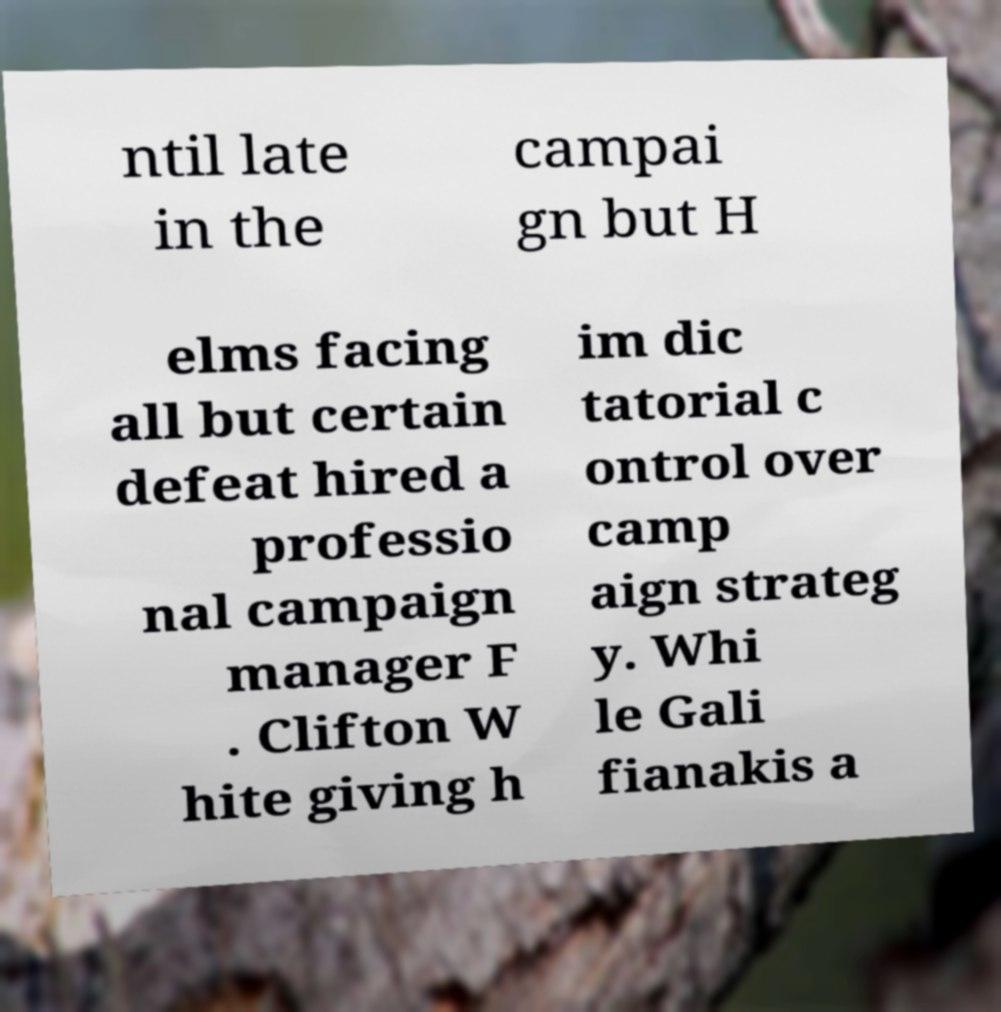Could you assist in decoding the text presented in this image and type it out clearly? ntil late in the campai gn but H elms facing all but certain defeat hired a professio nal campaign manager F . Clifton W hite giving h im dic tatorial c ontrol over camp aign strateg y. Whi le Gali fianakis a 